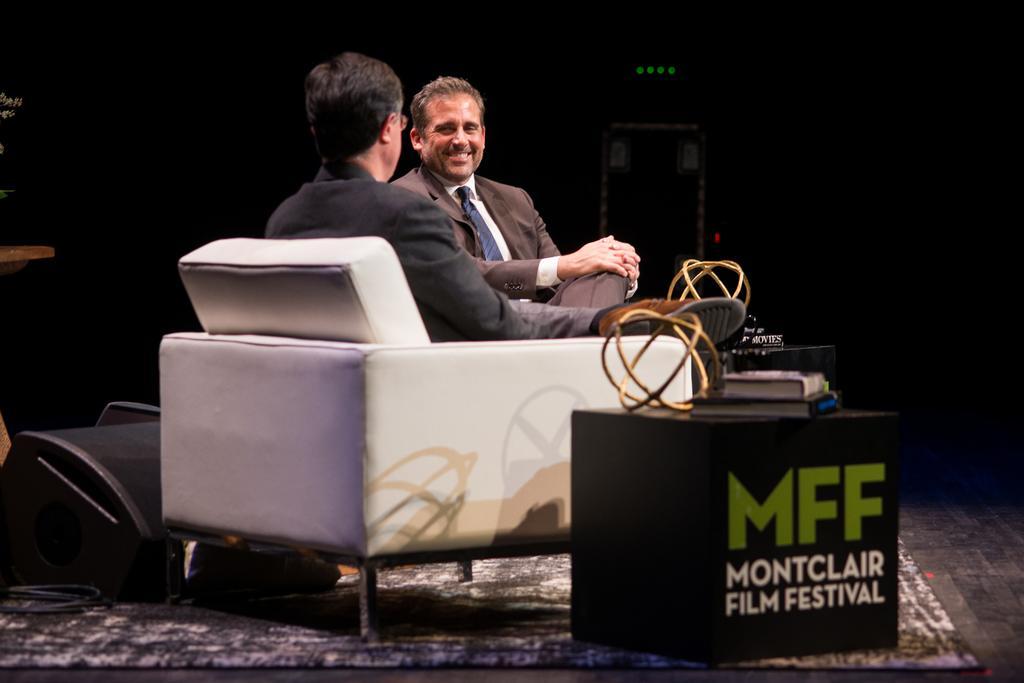Can you describe this image briefly? This 2 persons are sitting on a couch. In-front of this 2 persons there is a table, on a table there are books. This couch is in white color. 